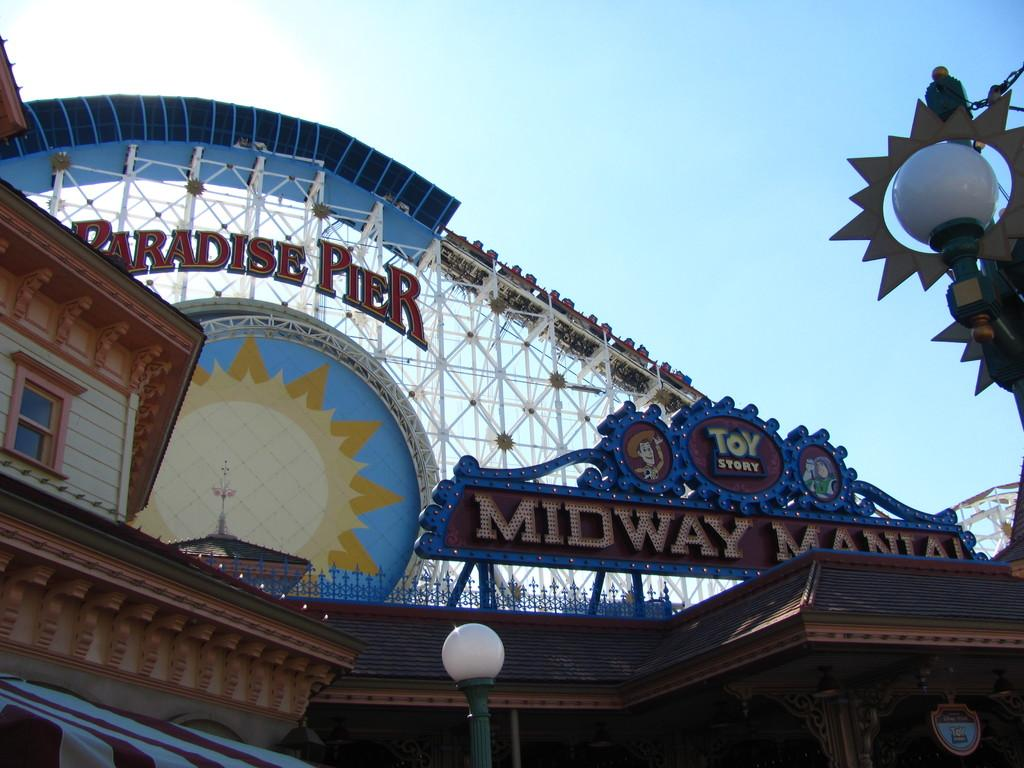<image>
Summarize the visual content of the image. A roller coaster on the midway at Paradise Pier. 